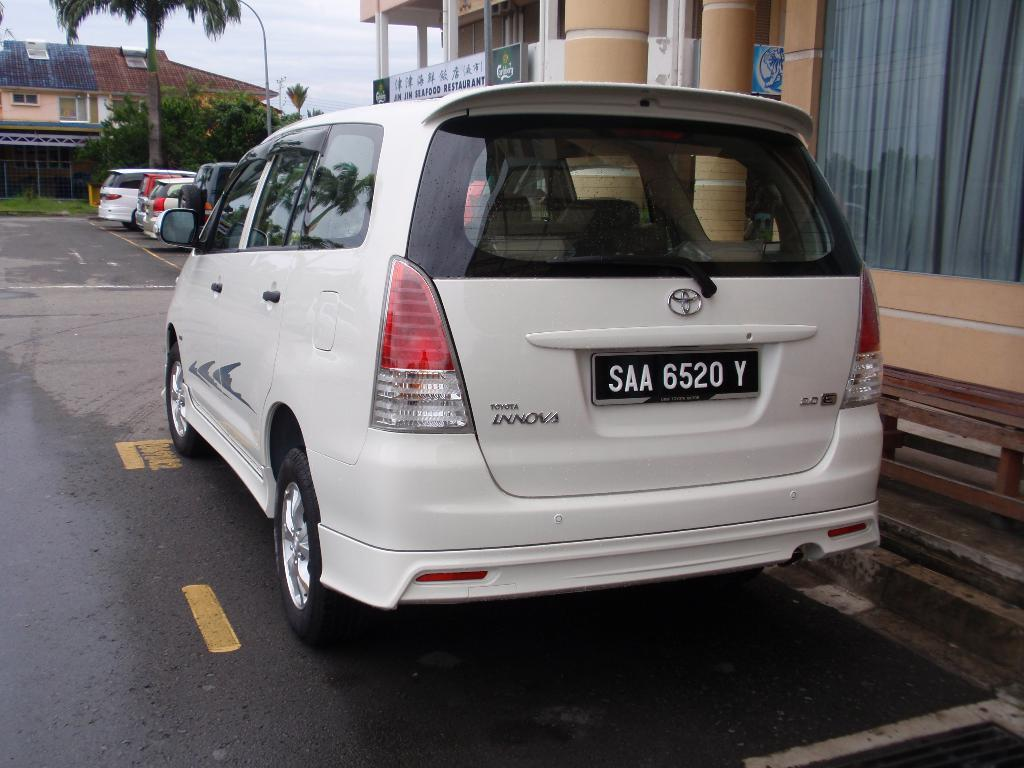<image>
Describe the image concisely. an SAA 6520 Y sign that is on a car 